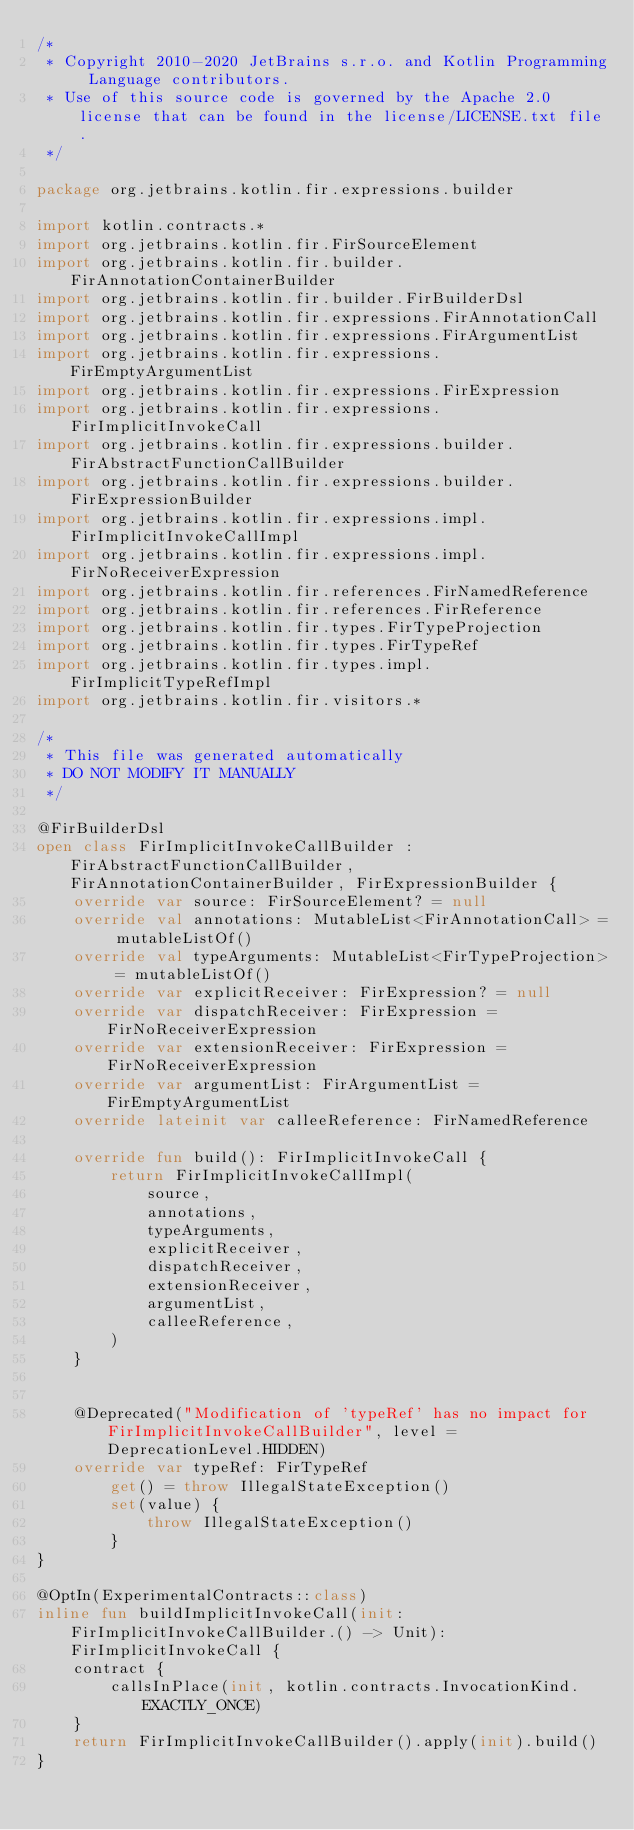<code> <loc_0><loc_0><loc_500><loc_500><_Kotlin_>/*
 * Copyright 2010-2020 JetBrains s.r.o. and Kotlin Programming Language contributors.
 * Use of this source code is governed by the Apache 2.0 license that can be found in the license/LICENSE.txt file.
 */

package org.jetbrains.kotlin.fir.expressions.builder

import kotlin.contracts.*
import org.jetbrains.kotlin.fir.FirSourceElement
import org.jetbrains.kotlin.fir.builder.FirAnnotationContainerBuilder
import org.jetbrains.kotlin.fir.builder.FirBuilderDsl
import org.jetbrains.kotlin.fir.expressions.FirAnnotationCall
import org.jetbrains.kotlin.fir.expressions.FirArgumentList
import org.jetbrains.kotlin.fir.expressions.FirEmptyArgumentList
import org.jetbrains.kotlin.fir.expressions.FirExpression
import org.jetbrains.kotlin.fir.expressions.FirImplicitInvokeCall
import org.jetbrains.kotlin.fir.expressions.builder.FirAbstractFunctionCallBuilder
import org.jetbrains.kotlin.fir.expressions.builder.FirExpressionBuilder
import org.jetbrains.kotlin.fir.expressions.impl.FirImplicitInvokeCallImpl
import org.jetbrains.kotlin.fir.expressions.impl.FirNoReceiverExpression
import org.jetbrains.kotlin.fir.references.FirNamedReference
import org.jetbrains.kotlin.fir.references.FirReference
import org.jetbrains.kotlin.fir.types.FirTypeProjection
import org.jetbrains.kotlin.fir.types.FirTypeRef
import org.jetbrains.kotlin.fir.types.impl.FirImplicitTypeRefImpl
import org.jetbrains.kotlin.fir.visitors.*

/*
 * This file was generated automatically
 * DO NOT MODIFY IT MANUALLY
 */

@FirBuilderDsl
open class FirImplicitInvokeCallBuilder : FirAbstractFunctionCallBuilder, FirAnnotationContainerBuilder, FirExpressionBuilder {
    override var source: FirSourceElement? = null
    override val annotations: MutableList<FirAnnotationCall> = mutableListOf()
    override val typeArguments: MutableList<FirTypeProjection> = mutableListOf()
    override var explicitReceiver: FirExpression? = null
    override var dispatchReceiver: FirExpression = FirNoReceiverExpression
    override var extensionReceiver: FirExpression = FirNoReceiverExpression
    override var argumentList: FirArgumentList = FirEmptyArgumentList
    override lateinit var calleeReference: FirNamedReference

    override fun build(): FirImplicitInvokeCall {
        return FirImplicitInvokeCallImpl(
            source,
            annotations,
            typeArguments,
            explicitReceiver,
            dispatchReceiver,
            extensionReceiver,
            argumentList,
            calleeReference,
        )
    }


    @Deprecated("Modification of 'typeRef' has no impact for FirImplicitInvokeCallBuilder", level = DeprecationLevel.HIDDEN)
    override var typeRef: FirTypeRef
        get() = throw IllegalStateException()
        set(value) {
            throw IllegalStateException()
        }
}

@OptIn(ExperimentalContracts::class)
inline fun buildImplicitInvokeCall(init: FirImplicitInvokeCallBuilder.() -> Unit): FirImplicitInvokeCall {
    contract {
        callsInPlace(init, kotlin.contracts.InvocationKind.EXACTLY_ONCE)
    }
    return FirImplicitInvokeCallBuilder().apply(init).build()
}
</code> 